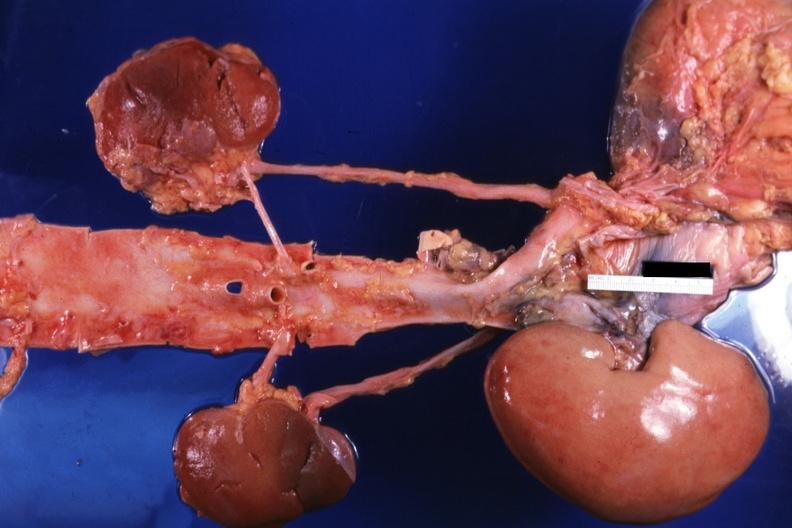s serous cyst placed relative to other structures?
Answer the question using a single word or phrase. No 